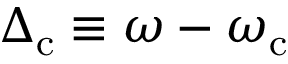Convert formula to latex. <formula><loc_0><loc_0><loc_500><loc_500>\Delta _ { c } \equiv \omega - \omega _ { c }</formula> 